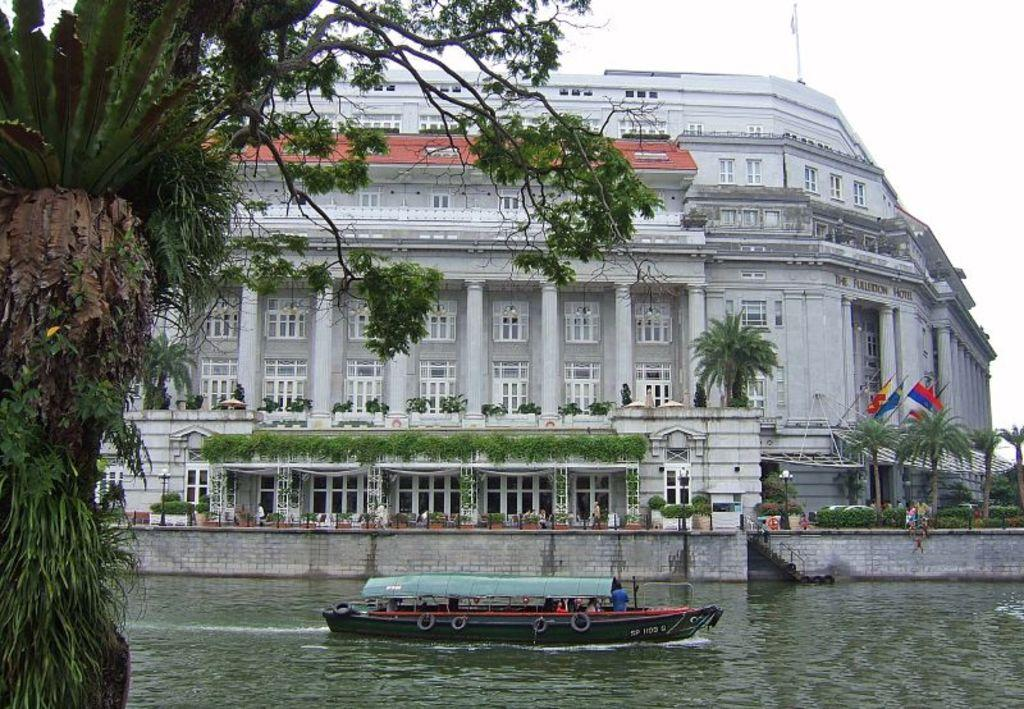What is the main subject of the image? The main subject of the image is a boat. Where is the boat located? The boat is on the water. What can be seen on the right side of the image? There are flags on the right side of the image. What type of structure is visible in the image? There is a building in the image. What type of vegetation is present in the image? There are trees in the image. What is visible in the sky in the image? Clouds are visible in the sky. What type of house is depicted in the image? There is no house present in the image; it features a boat on the water with flags, a building, trees, and clouds in the sky. What part of the human body can be seen interacting with the boat in the image? There are no human body parts visible in the image; it only shows a boat, flags, a building, trees, and clouds. 